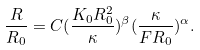Convert formula to latex. <formula><loc_0><loc_0><loc_500><loc_500>\frac { R } { R _ { 0 } } = C ( \frac { K _ { 0 } R _ { 0 } ^ { 2 } } { \kappa } ) ^ { \beta } ( \frac { \kappa } { F R _ { 0 } } ) ^ { \alpha } .</formula> 